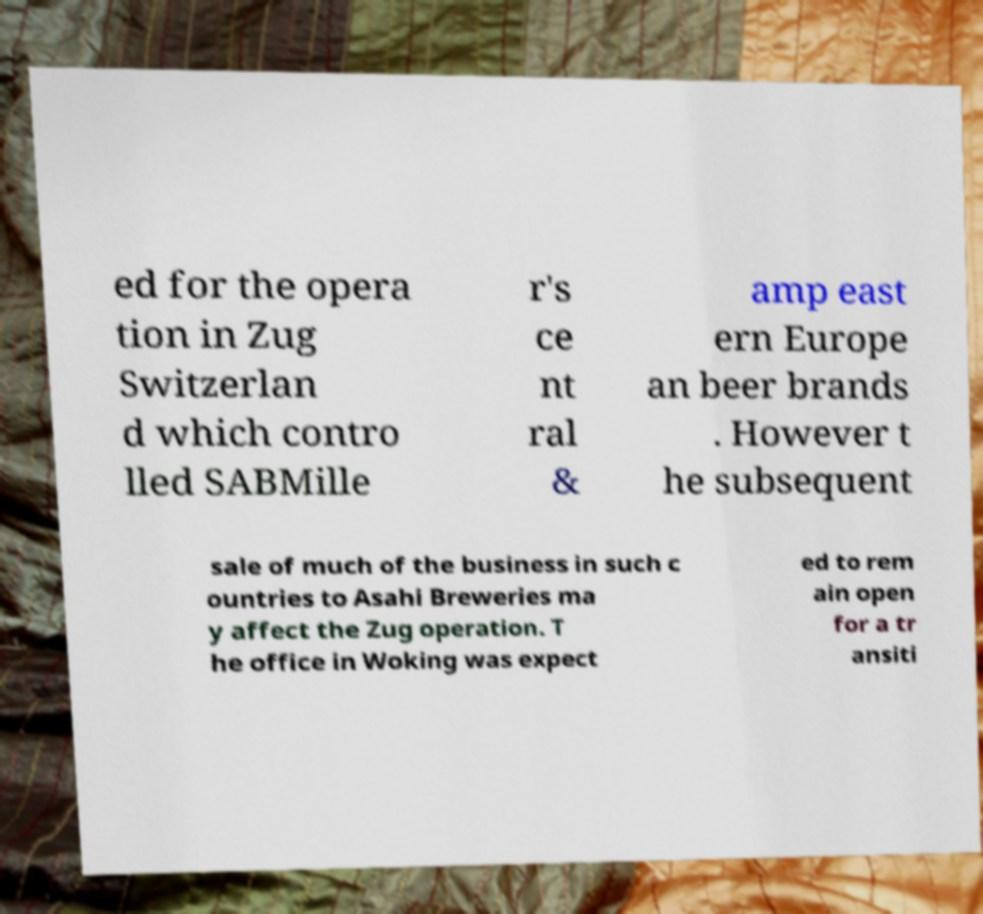Please read and relay the text visible in this image. What does it say? ed for the opera tion in Zug Switzerlan d which contro lled SABMille r's ce nt ral & amp east ern Europe an beer brands . However t he subsequent sale of much of the business in such c ountries to Asahi Breweries ma y affect the Zug operation. T he office in Woking was expect ed to rem ain open for a tr ansiti 